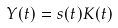<formula> <loc_0><loc_0><loc_500><loc_500>Y ( t ) = s ( t ) K ( t )</formula> 